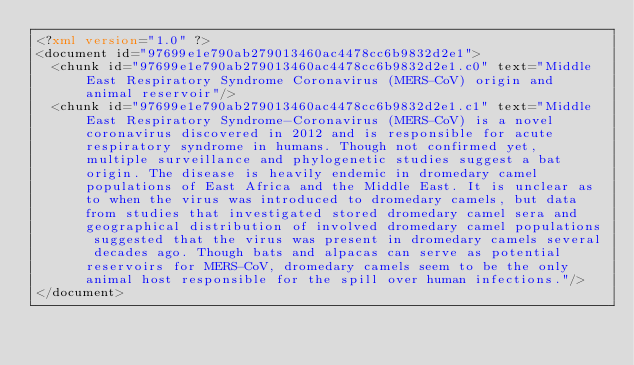Convert code to text. <code><loc_0><loc_0><loc_500><loc_500><_XML_><?xml version="1.0" ?>
<document id="97699e1e790ab279013460ac4478cc6b9832d2e1">
  <chunk id="97699e1e790ab279013460ac4478cc6b9832d2e1.c0" text="Middle East Respiratory Syndrome Coronavirus (MERS-CoV) origin and animal reservoir"/>
  <chunk id="97699e1e790ab279013460ac4478cc6b9832d2e1.c1" text="Middle East Respiratory Syndrome-Coronavirus (MERS-CoV) is a novel coronavirus discovered in 2012 and is responsible for acute respiratory syndrome in humans. Though not confirmed yet, multiple surveillance and phylogenetic studies suggest a bat origin. The disease is heavily endemic in dromedary camel populations of East Africa and the Middle East. It is unclear as to when the virus was introduced to dromedary camels, but data from studies that investigated stored dromedary camel sera and geographical distribution of involved dromedary camel populations suggested that the virus was present in dromedary camels several decades ago. Though bats and alpacas can serve as potential reservoirs for MERS-CoV, dromedary camels seem to be the only animal host responsible for the spill over human infections."/>
</document>
</code> 